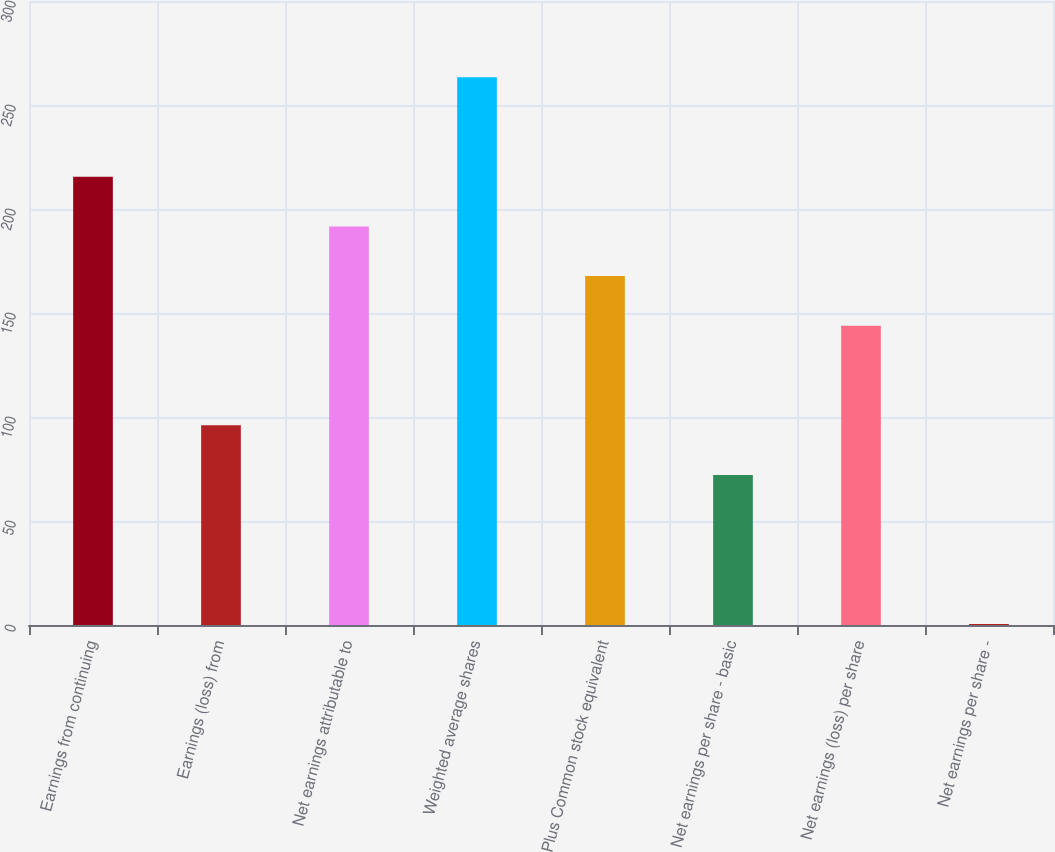Convert chart. <chart><loc_0><loc_0><loc_500><loc_500><bar_chart><fcel>Earnings from continuing<fcel>Earnings (loss) from<fcel>Net earnings attributable to<fcel>Weighted average shares<fcel>Plus Common stock equivalent<fcel>Net earnings per share - basic<fcel>Net earnings (loss) per share<fcel>Net earnings per share -<nl><fcel>215.54<fcel>96.04<fcel>191.64<fcel>263.34<fcel>167.74<fcel>72.14<fcel>143.84<fcel>0.44<nl></chart> 